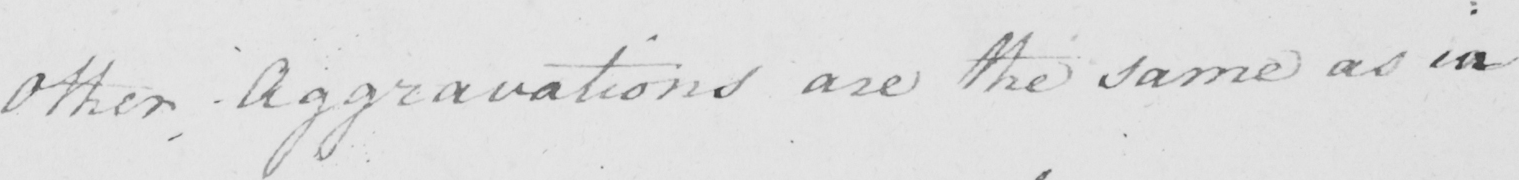Can you tell me what this handwritten text says? Other Aggravations are the same as in 